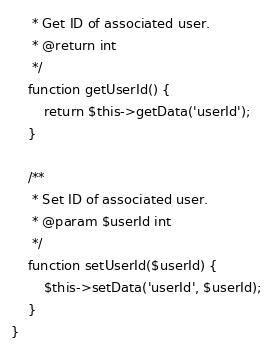Convert code to text. <code><loc_0><loc_0><loc_500><loc_500><_PHP_>	 * Get ID of associated user.
	 * @return int
	 */
	function getUserId() {
		return $this->getData('userId');
	}

	/**
	 * Set ID of associated user.
	 * @param $userId int
	 */
	function setUserId($userId) {
		$this->setData('userId', $userId);
	}
}


</code> 